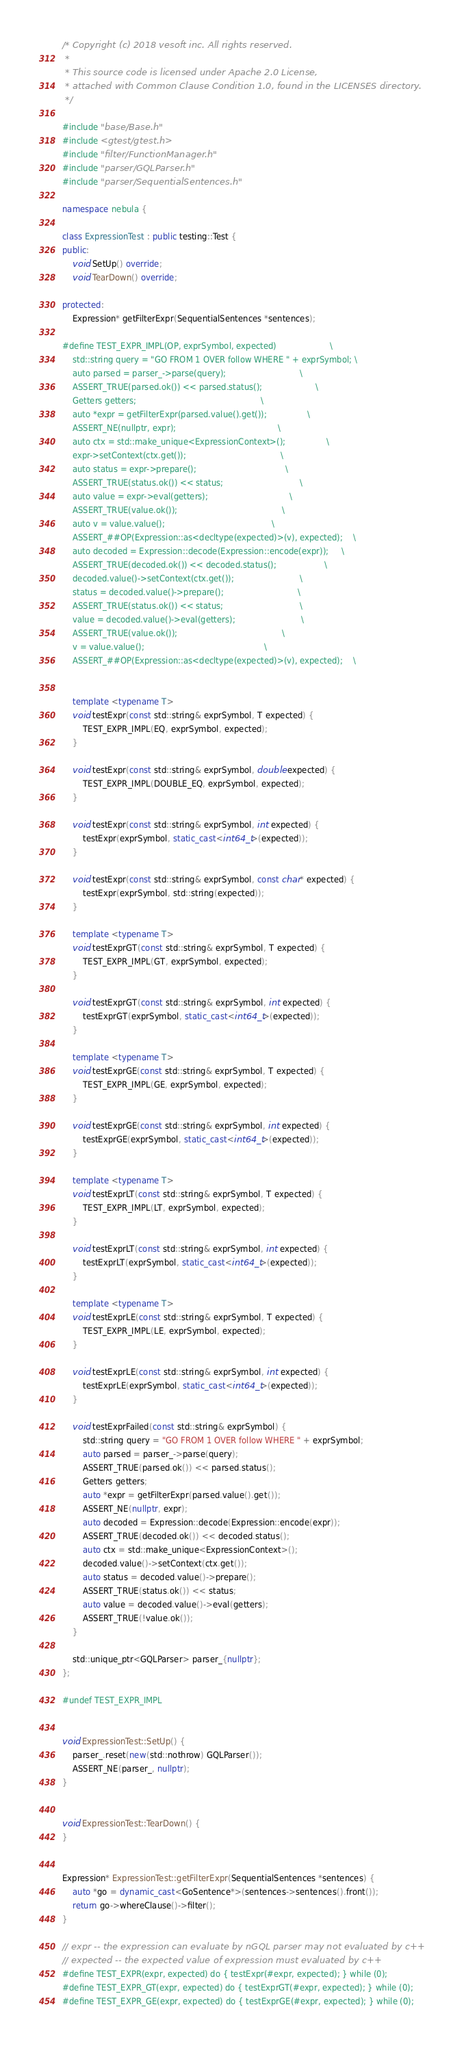<code> <loc_0><loc_0><loc_500><loc_500><_C++_>/* Copyright (c) 2018 vesoft inc. All rights reserved.
 *
 * This source code is licensed under Apache 2.0 License,
 * attached with Common Clause Condition 1.0, found in the LICENSES directory.
 */

#include "base/Base.h"
#include <gtest/gtest.h>
#include "filter/FunctionManager.h"
#include "parser/GQLParser.h"
#include "parser/SequentialSentences.h"

namespace nebula {

class ExpressionTest : public testing::Test {
public:
    void SetUp() override;
    void TearDown() override;

protected:
    Expression* getFilterExpr(SequentialSentences *sentences);

#define TEST_EXPR_IMPL(OP, exprSymbol, expected)                     \
    std::string query = "GO FROM 1 OVER follow WHERE " + exprSymbol; \
    auto parsed = parser_->parse(query);                             \
    ASSERT_TRUE(parsed.ok()) << parsed.status();                     \
    Getters getters;                                                 \
    auto *expr = getFilterExpr(parsed.value().get());                \
    ASSERT_NE(nullptr, expr);                                        \
    auto ctx = std::make_unique<ExpressionContext>();                \
    expr->setContext(ctx.get());                                     \
    auto status = expr->prepare();                                   \
    ASSERT_TRUE(status.ok()) << status;                              \
    auto value = expr->eval(getters);                                \
    ASSERT_TRUE(value.ok());                                         \
    auto v = value.value();                                          \
    ASSERT_##OP(Expression::as<decltype(expected)>(v), expected);    \
    auto decoded = Expression::decode(Expression::encode(expr));     \
    ASSERT_TRUE(decoded.ok()) << decoded.status();                   \
    decoded.value()->setContext(ctx.get());                          \
    status = decoded.value()->prepare();                             \
    ASSERT_TRUE(status.ok()) << status;                              \
    value = decoded.value()->eval(getters);                          \
    ASSERT_TRUE(value.ok());                                         \
    v = value.value();                                               \
    ASSERT_##OP(Expression::as<decltype(expected)>(v), expected);    \


    template <typename T>
    void testExpr(const std::string& exprSymbol, T expected) {
        TEST_EXPR_IMPL(EQ, exprSymbol, expected);
    }

    void testExpr(const std::string& exprSymbol, double expected) {
        TEST_EXPR_IMPL(DOUBLE_EQ, exprSymbol, expected);
    }

    void testExpr(const std::string& exprSymbol, int expected) {
        testExpr(exprSymbol, static_cast<int64_t>(expected));
    }

    void testExpr(const std::string& exprSymbol, const char* expected) {
        testExpr(exprSymbol, std::string(expected));
    }

    template <typename T>
    void testExprGT(const std::string& exprSymbol, T expected) {
        TEST_EXPR_IMPL(GT, exprSymbol, expected);
    }

    void testExprGT(const std::string& exprSymbol, int expected) {
        testExprGT(exprSymbol, static_cast<int64_t>(expected));
    }

    template <typename T>
    void testExprGE(const std::string& exprSymbol, T expected) {
        TEST_EXPR_IMPL(GE, exprSymbol, expected);
    }

    void testExprGE(const std::string& exprSymbol, int expected) {
        testExprGE(exprSymbol, static_cast<int64_t>(expected));
    }

    template <typename T>
    void testExprLT(const std::string& exprSymbol, T expected) {
        TEST_EXPR_IMPL(LT, exprSymbol, expected);
    }

    void testExprLT(const std::string& exprSymbol, int expected) {
        testExprLT(exprSymbol, static_cast<int64_t>(expected));
    }

    template <typename T>
    void testExprLE(const std::string& exprSymbol, T expected) {
        TEST_EXPR_IMPL(LE, exprSymbol, expected);
    }

    void testExprLE(const std::string& exprSymbol, int expected) {
        testExprLE(exprSymbol, static_cast<int64_t>(expected));
    }

    void testExprFailed(const std::string& exprSymbol) {
        std::string query = "GO FROM 1 OVER follow WHERE " + exprSymbol;
        auto parsed = parser_->parse(query);
        ASSERT_TRUE(parsed.ok()) << parsed.status();
        Getters getters;
        auto *expr = getFilterExpr(parsed.value().get());
        ASSERT_NE(nullptr, expr);
        auto decoded = Expression::decode(Expression::encode(expr));
        ASSERT_TRUE(decoded.ok()) << decoded.status();
        auto ctx = std::make_unique<ExpressionContext>();
        decoded.value()->setContext(ctx.get());
        auto status = decoded.value()->prepare();
        ASSERT_TRUE(status.ok()) << status;
        auto value = decoded.value()->eval(getters);
        ASSERT_TRUE(!value.ok());
    }

    std::unique_ptr<GQLParser> parser_{nullptr};
};

#undef TEST_EXPR_IMPL


void ExpressionTest::SetUp() {
    parser_.reset(new(std::nothrow) GQLParser());
    ASSERT_NE(parser_, nullptr);
}


void ExpressionTest::TearDown() {
}


Expression* ExpressionTest::getFilterExpr(SequentialSentences *sentences) {
    auto *go = dynamic_cast<GoSentence*>(sentences->sentences().front());
    return go->whereClause()->filter();
}

// expr -- the expression can evaluate by nGQL parser may not evaluated by c++
// expected -- the expected value of expression must evaluated by c++
#define TEST_EXPR(expr, expected) do { testExpr(#expr, expected); } while (0);
#define TEST_EXPR_GT(expr, expected) do { testExprGT(#expr, expected); } while (0);
#define TEST_EXPR_GE(expr, expected) do { testExprGE(#expr, expected); } while (0);</code> 